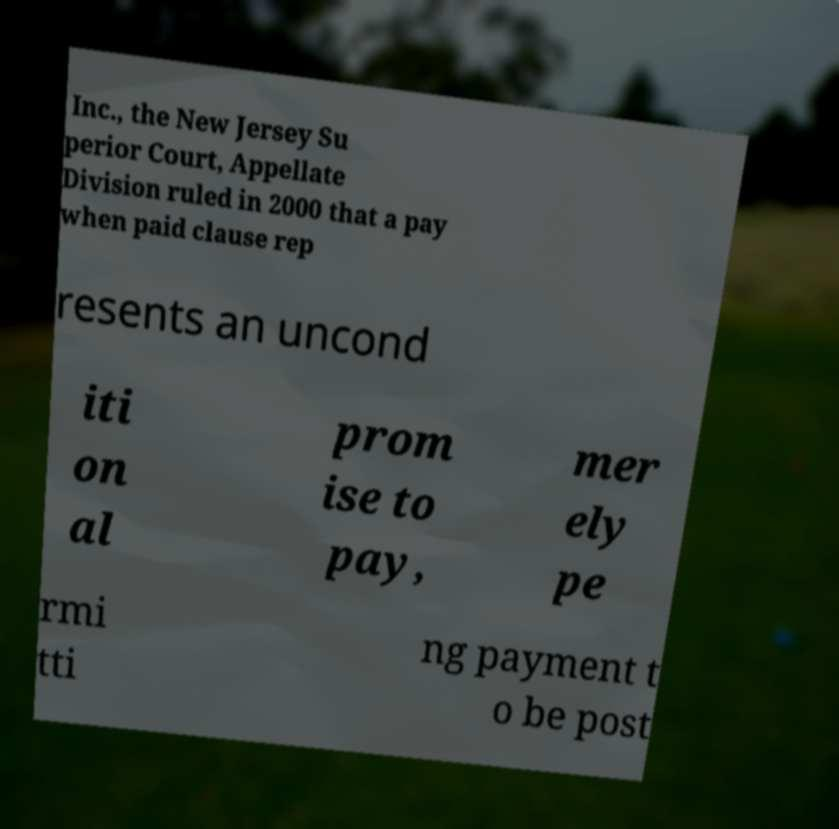There's text embedded in this image that I need extracted. Can you transcribe it verbatim? Inc., the New Jersey Su perior Court, Appellate Division ruled in 2000 that a pay when paid clause rep resents an uncond iti on al prom ise to pay, mer ely pe rmi tti ng payment t o be post 